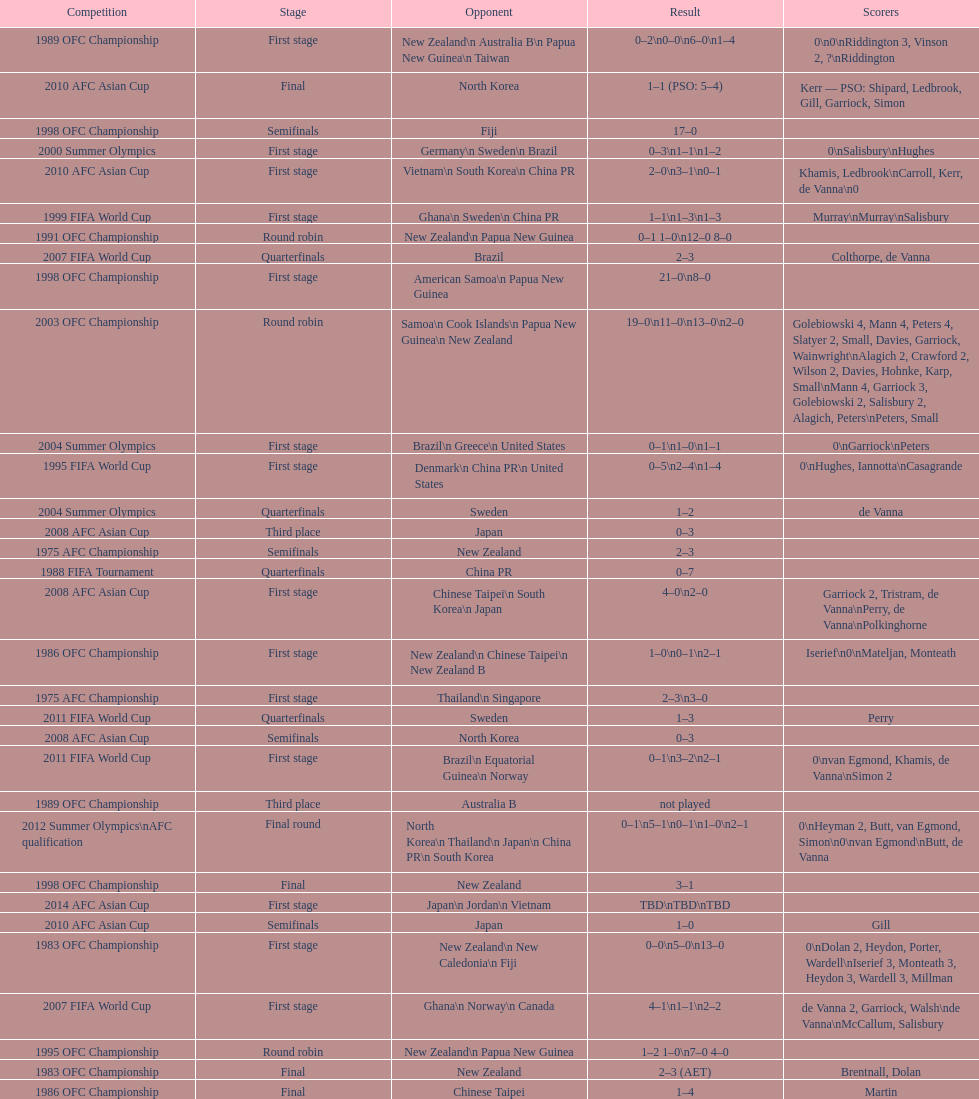What was the complete goal count in the 1983 ofc championship? 18. 